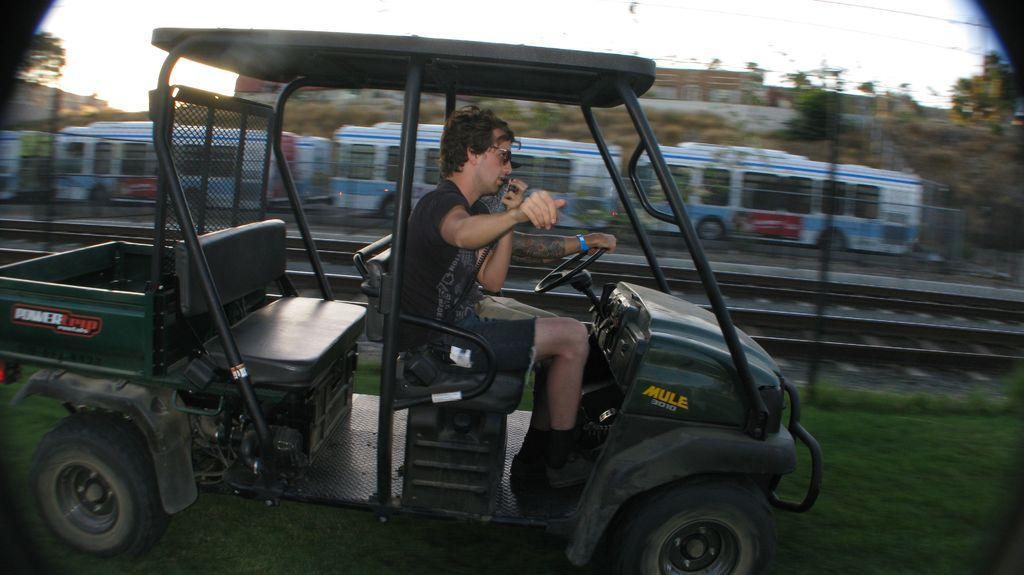Describe this image in one or two sentences. This is the picture of a person in the vehicle and to the side there is a train on the track and some trees around. 